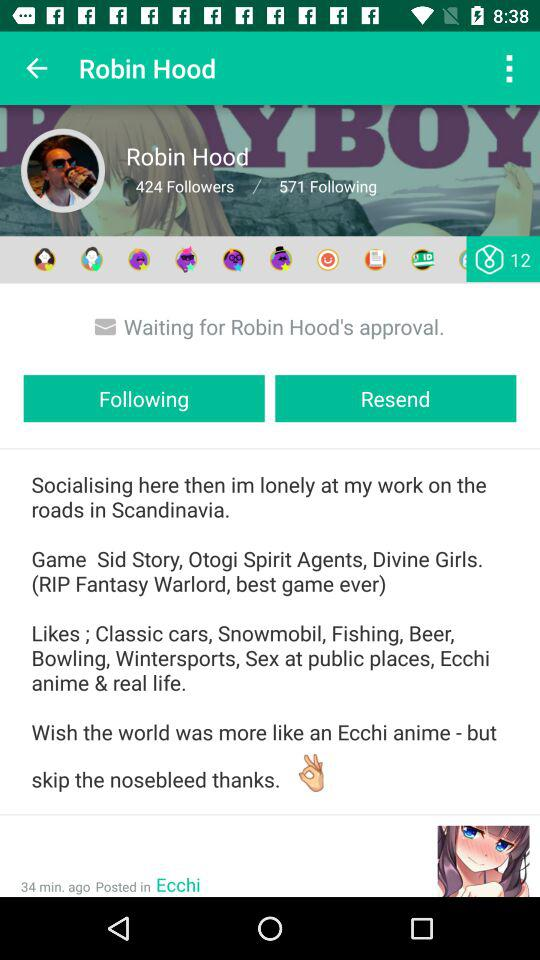What's the user profile name? The user profile name is Robin Hood. 